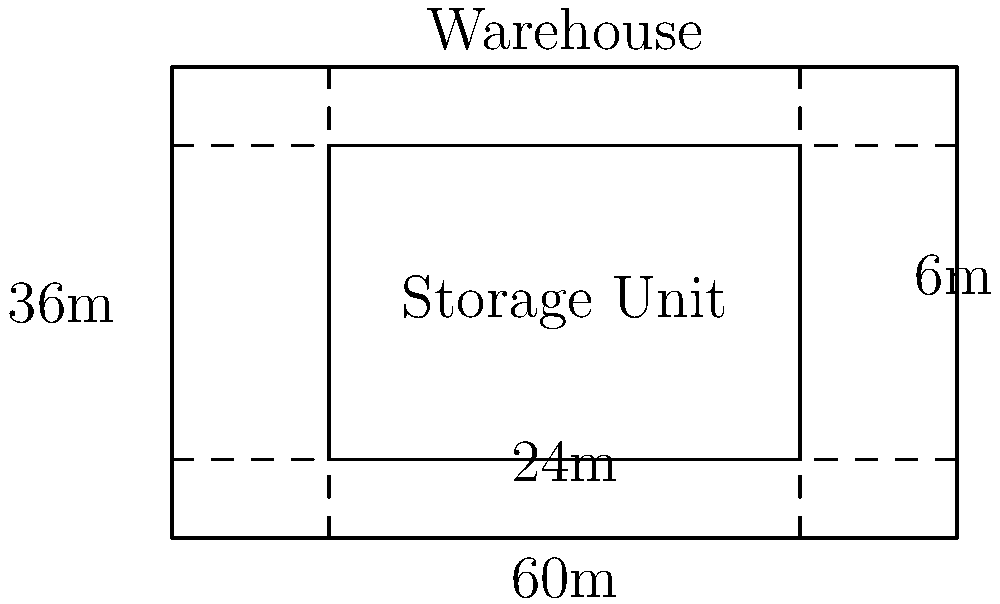As a successful entrepreneur, you're optimizing your warehouse space. You have a rectangular warehouse measuring 60m by 36m. You plan to use rectangular storage units measuring 24m by 24m. What's the maximum number of these storage units that can fit in the warehouse while maintaining a 6m wide aisle along two adjacent sides for forklift access? Let's approach this step-by-step:

1) First, we need to calculate the available space after accounting for the aisles:
   - Width available = 60m - 6m = 54m
   - Length available = 36m - 6m = 30m

2) Now, we need to determine how many storage units can fit in each dimension:
   - Number of units along width = 54m ÷ 24m = 2.25
   - Number of units along length = 30m ÷ 24m = 1.25

3) Since we can't have partial units, we round down to the nearest whole number:
   - Units along width = 2
   - Units along length = 1

4) To calculate the total number of units, we multiply:
   $$ \text{Total units} = 2 \times 1 = 2 $$

Therefore, the maximum number of 24m by 24m storage units that can fit in the warehouse while maintaining the required aisle space is 2.
Answer: 2 storage units 